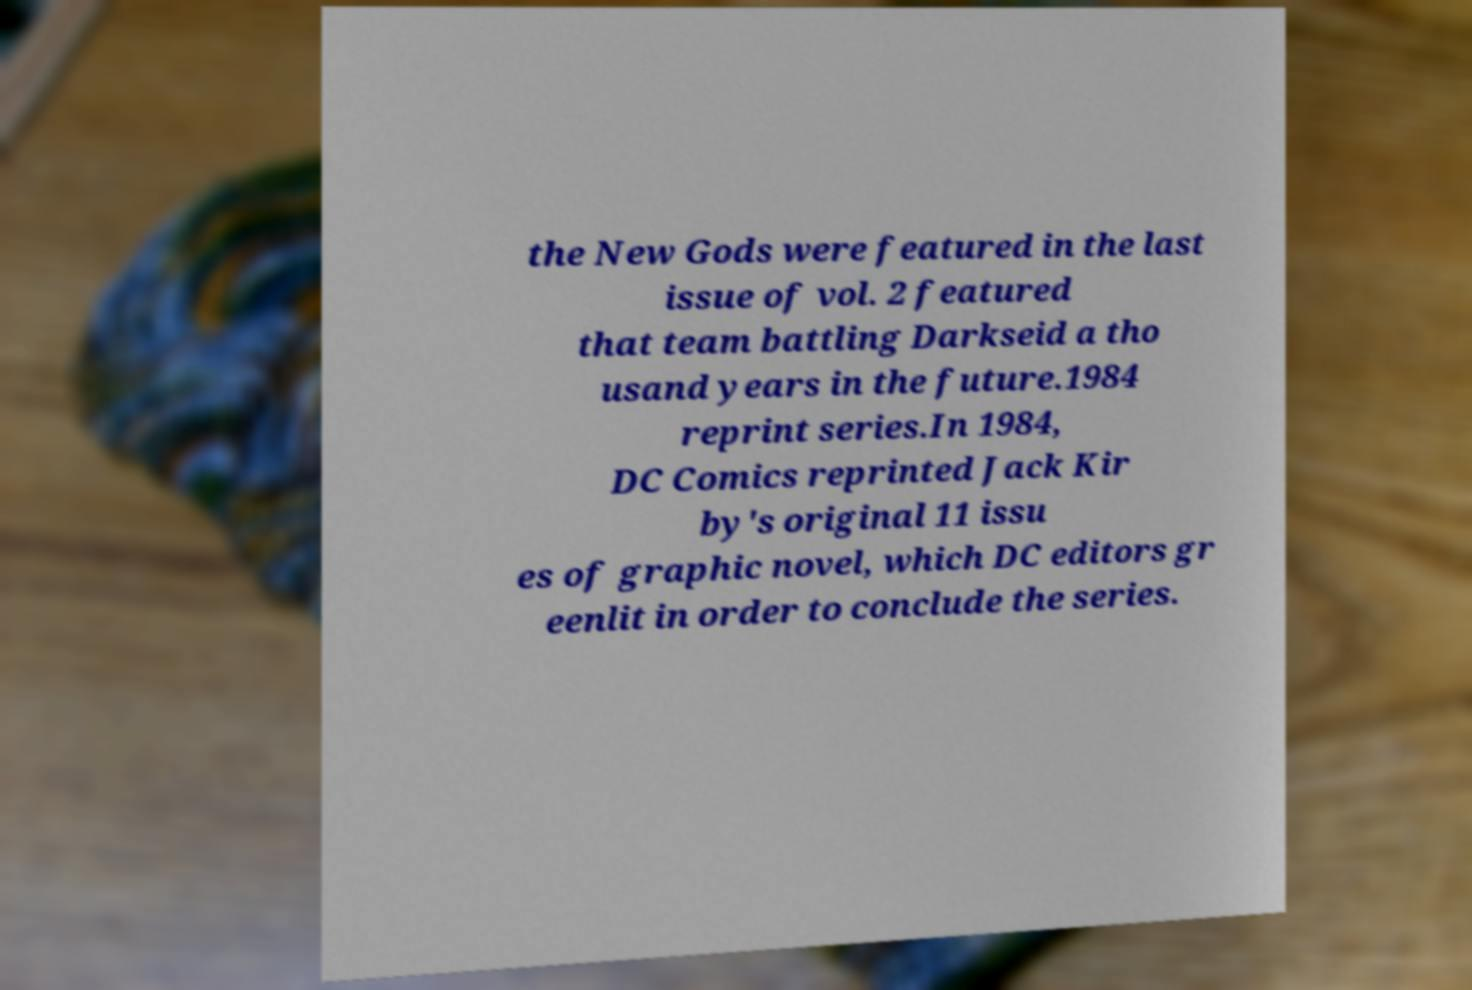Can you accurately transcribe the text from the provided image for me? the New Gods were featured in the last issue of vol. 2 featured that team battling Darkseid a tho usand years in the future.1984 reprint series.In 1984, DC Comics reprinted Jack Kir by's original 11 issu es of graphic novel, which DC editors gr eenlit in order to conclude the series. 